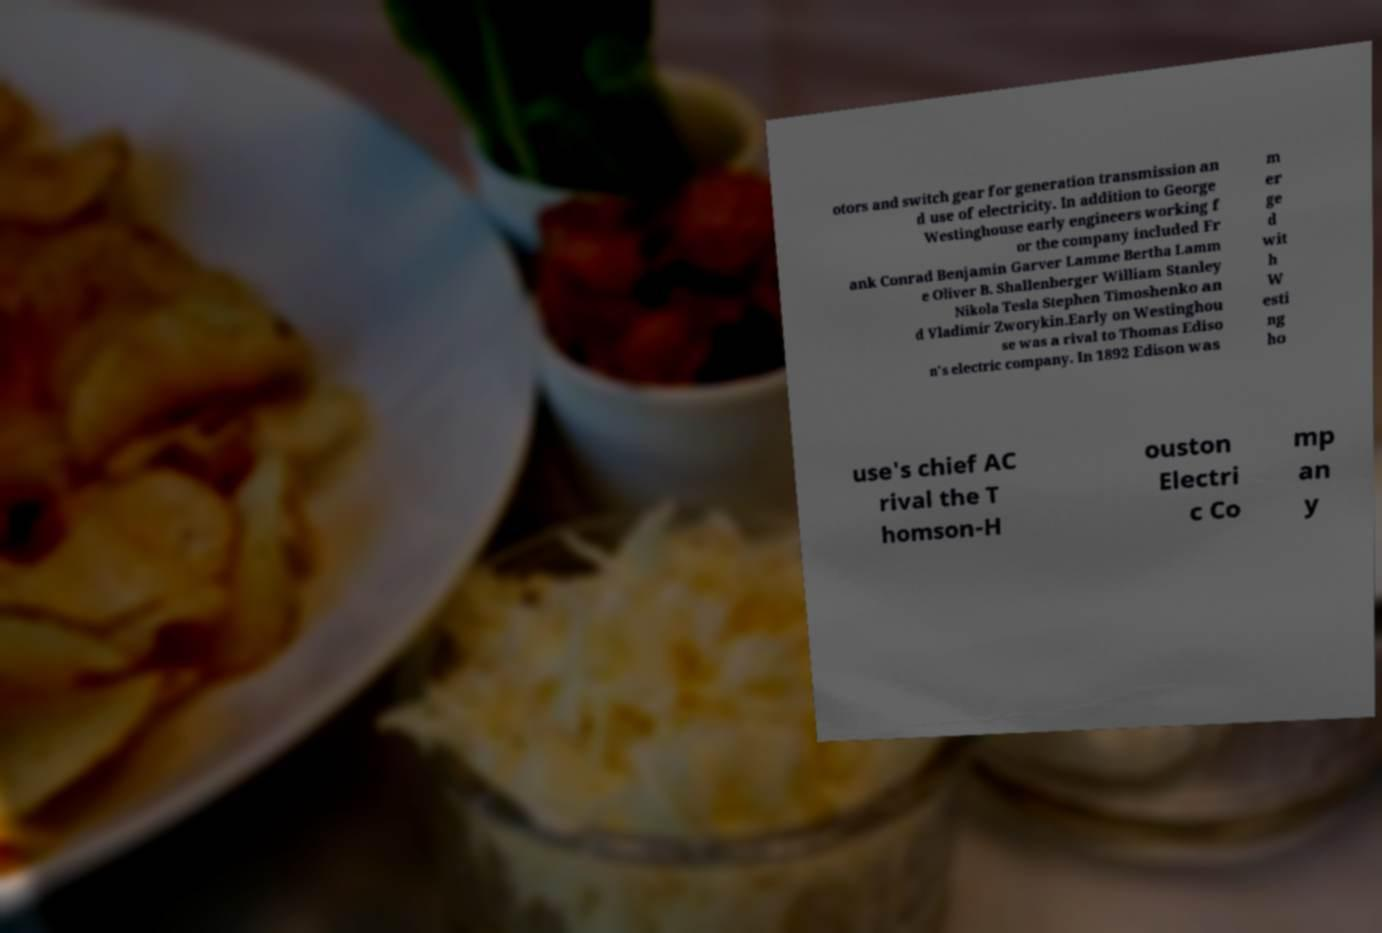Can you accurately transcribe the text from the provided image for me? otors and switch gear for generation transmission an d use of electricity. In addition to George Westinghouse early engineers working f or the company included Fr ank Conrad Benjamin Garver Lamme Bertha Lamm e Oliver B. Shallenberger William Stanley Nikola Tesla Stephen Timoshenko an d Vladimir Zworykin.Early on Westinghou se was a rival to Thomas Ediso n's electric company. In 1892 Edison was m er ge d wit h W esti ng ho use's chief AC rival the T homson-H ouston Electri c Co mp an y 